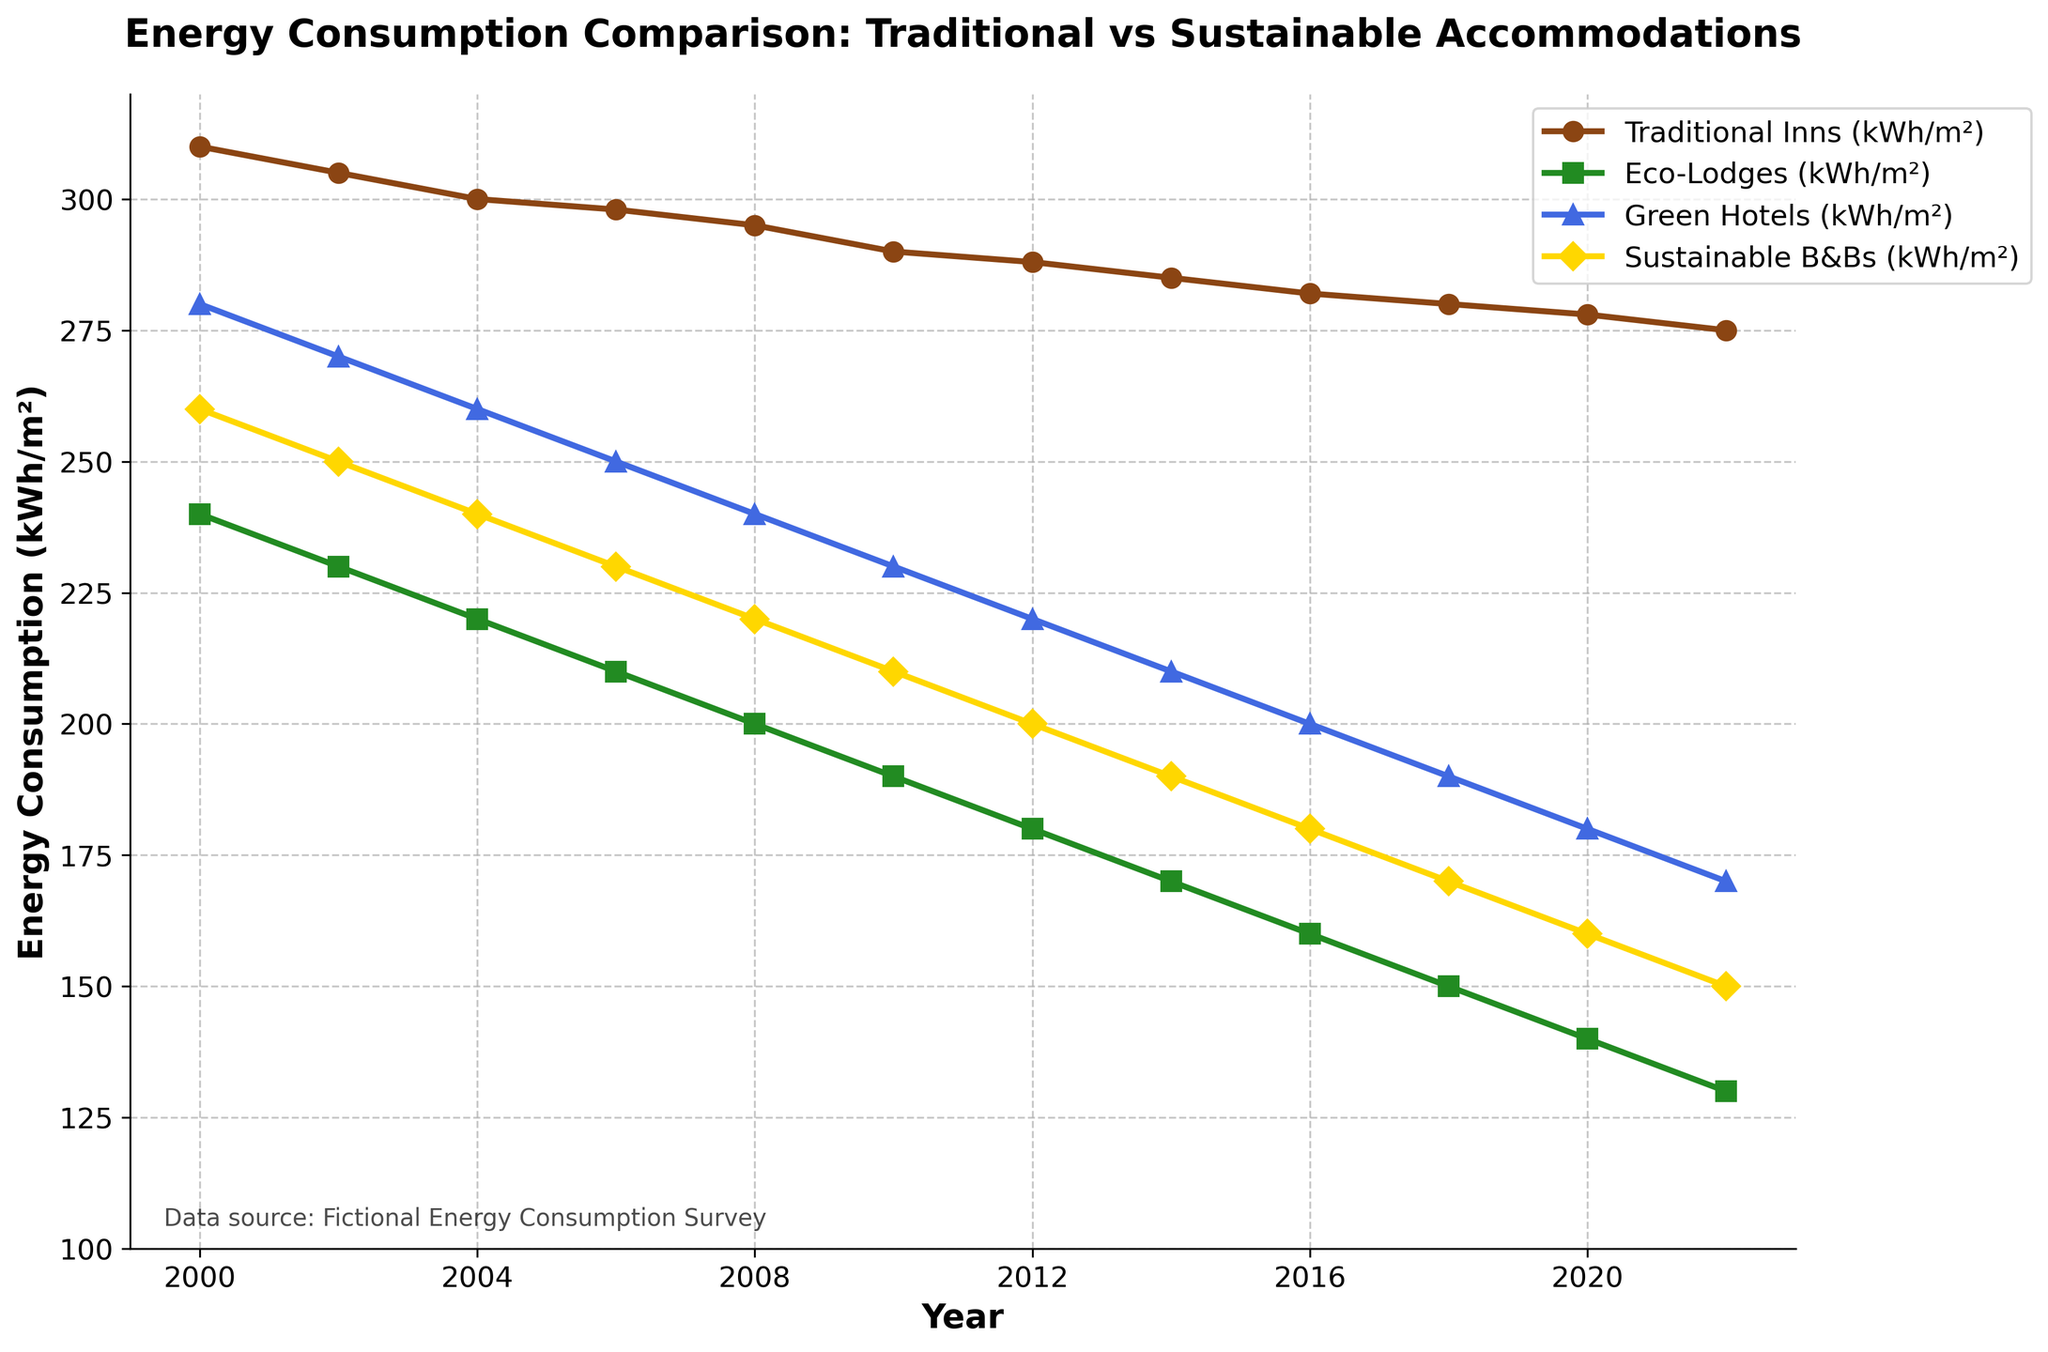What is the trend in energy consumption for Traditional Inns from 2000 to 2022? The energy consumption for Traditional Inns shows a steady decline over the years. In 2000, they started at 310 kWh/m² and gradually decreased to 275 kWh/m² by 2022
Answer: Steady decline Which accommodation type had the lowest energy consumption in 2022? By observing the graph, Eco-Lodges had the lowest energy consumption in 2022, with a value of 130 kWh/m²
Answer: Eco-Lodges Between 2008 and 2012, how did the energy consumption of Sustainable B&Bs change? In 2008, the energy consumption for Sustainable B&Bs was 220 kWh/m². By 2012, it had decreased to 200 kWh/m², indicating a reduction of 20 kWh/m².
Answer: Decreased by 20 kWh/m² Compare the energy consumption between Green Hotels and Traditional Inns in 2020. In 2020, Green Hotels had an energy consumption of 180 kWh/m², whereas Traditional Inns had 278 kWh/m². Green Hotels consumed 98 kWh/m² less energy.
Answer: Green Hotels consumed 98 kWh/m² less energy Which year did Traditional Inns and Eco-Lodges have the same difference in their energy consumption compared to 2002? Traditional Inns decreased from 305 kWh/m² in 2002 to 282 kWh/m² in 2016, a difference of 23 kWh/m². Eco-Lodges reduced from 230 kWh/m² in 2002 to 160 kWh/m² in 2016, a difference of 70 kWh/m². They didn't have the same difference in any year from 2002 to 2022
Answer: None What is the average energy consumption of Green Hotels from 2000 to 2022? Summing the values for Green Hotels from each year (280 + 270 + 260 + 250 + 240 + 230 + 220 + 210 + 200 + 190 + 180 + 170) = 2720 kWh/m². There are 12 data points, so the average is 2720/12
Answer: 226.67 kWh/m² In which year did Sustainable B&Bs see the largest single-year decrease? The largest decrease for Sustainable B&Bs occurred between 2006 and 2008, where it dropped from 230 kWh/m² to 220 kWh/m², a decrease of 10 kWh/m²
Answer: 2008 Describe the rate of decline of energy consumption for Eco-Lodges between 2000 and 2014. In 2000, Eco-Lodges' energy consumption was 240 kWh/m² and it dropped to 170 kWh/m² in 2014. Over 14 years, the total decline was 70 kWh/m². The average annual decline rate is 70/14 = 5 kWh/m² per year
Answer: 5 kWh/m² per year 